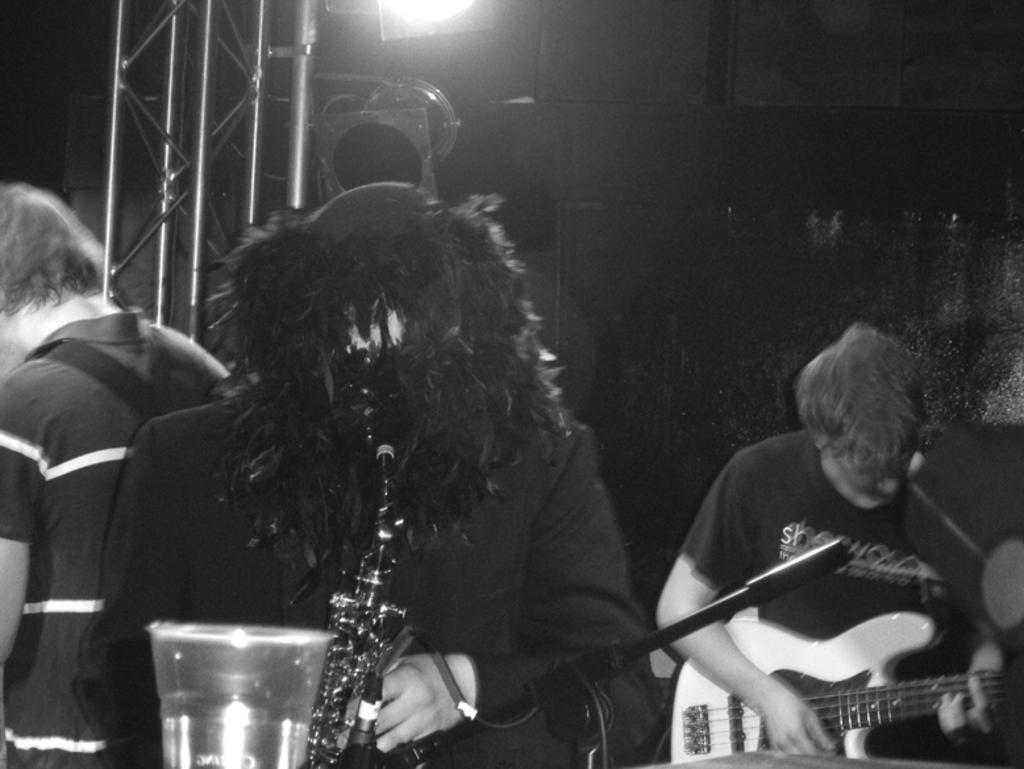How many people are in the image? There are three persons in the image. What are two of the persons doing? Two of the persons are holding musical instruments. Can you describe the background of the image? There is light visible in the background of the image. What type of flowers can be seen in the image? There are no flowers present in the image. What sound can be heard coming from the musical instruments in the image? The image is static, so no sound can be heard. 